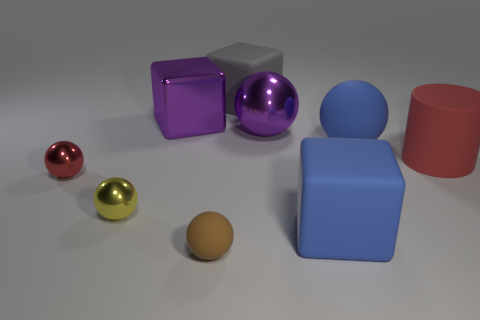How many other small rubber objects have the same shape as the small red thing?
Your answer should be compact. 1. What is the small yellow object made of?
Keep it short and to the point. Metal. Are there the same number of big blue rubber balls in front of the large red rubber cylinder and small yellow metal objects?
Your response must be concise. No. The purple metallic thing that is the same size as the purple shiny ball is what shape?
Your answer should be compact. Cube. Are there any gray rubber cubes that are in front of the matte ball to the right of the brown rubber sphere?
Provide a short and direct response. No. What number of big things are either yellow cylinders or objects?
Provide a short and direct response. 6. Are there any blue metal things of the same size as the red cylinder?
Give a very brief answer. No. What number of rubber objects are either brown objects or tiny balls?
Make the answer very short. 1. There is a big shiny thing that is the same color as the big shiny sphere; what shape is it?
Offer a very short reply. Cube. What number of small purple blocks are there?
Make the answer very short. 0. 